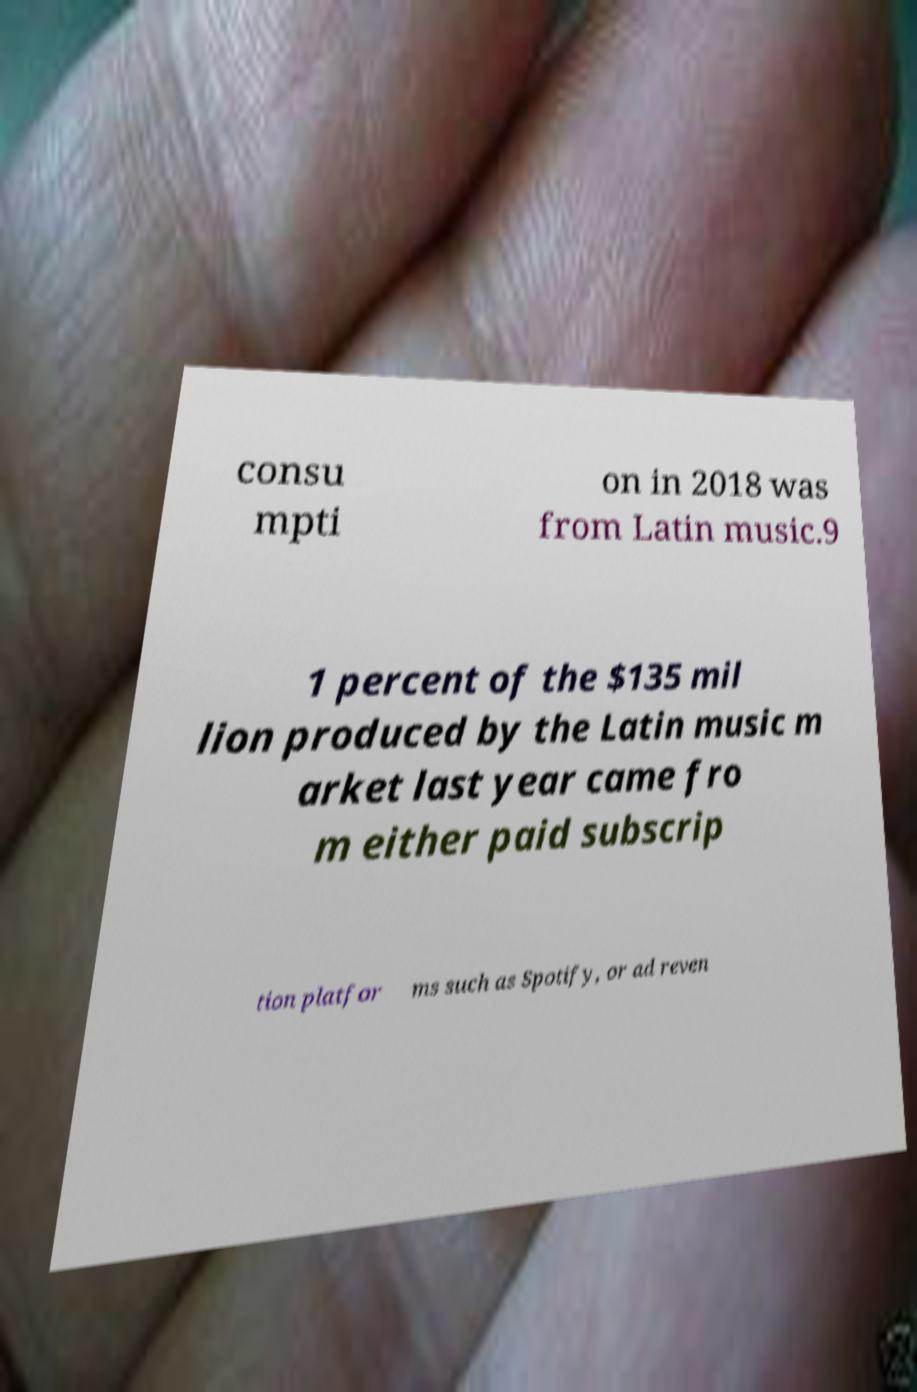I need the written content from this picture converted into text. Can you do that? consu mpti on in 2018 was from Latin music.9 1 percent of the $135 mil lion produced by the Latin music m arket last year came fro m either paid subscrip tion platfor ms such as Spotify, or ad reven 